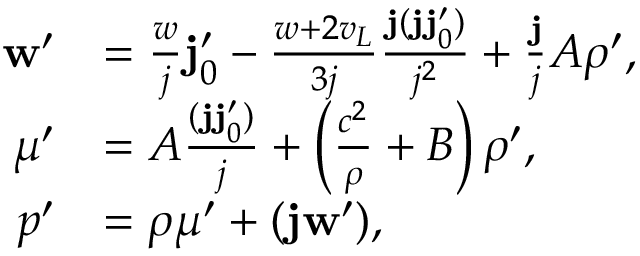Convert formula to latex. <formula><loc_0><loc_0><loc_500><loc_500>\begin{array} { r l } { { w ^ { \prime } } } & { = \frac { w } { j } { j _ { 0 } ^ { \prime } } - \frac { w + 2 v _ { L } } { 3 j } \frac { { j } ( { j } { j _ { 0 } ^ { \prime } } ) } { j ^ { 2 } } + \frac { { j } } { j } A { \rho ^ { \prime } } , } \\ { { \mu ^ { \prime } } } & { = A \frac { ( { j } { j _ { 0 } ^ { \prime } } ) } { j } + \left ( \frac { c ^ { 2 } } { \rho } + B \right ) { \rho ^ { \prime } } , } \\ { p ^ { \prime } } & { = \rho \mu ^ { \prime } + ( { j } { w ^ { \prime } } ) , } \end{array}</formula> 